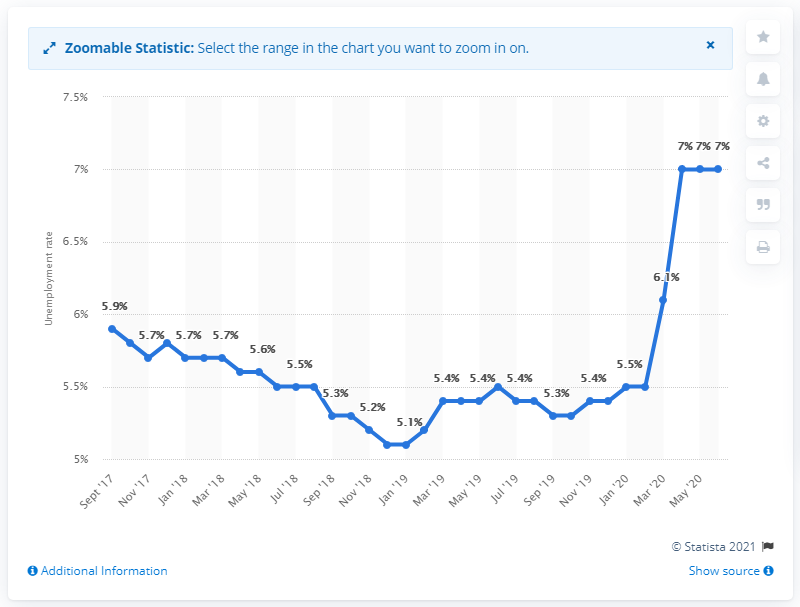What might explain the sudden increase in the unemployment rate shown at the end of the chart? While the image doesn't provide specific reasons, such a sudden increase is often attributable to external shocks such as economic crises, policy changes, or global events like the COVID-19 pandemic which has had significant economic impact worldwide. 